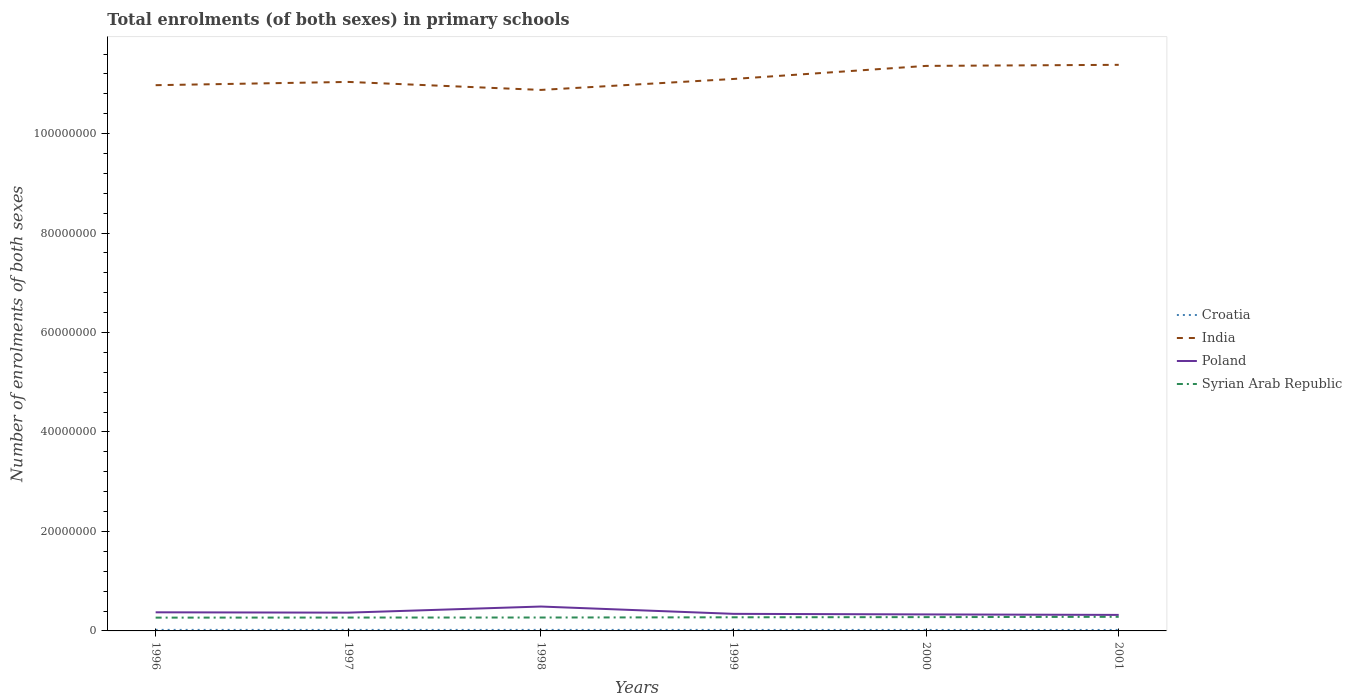Does the line corresponding to Syrian Arab Republic intersect with the line corresponding to India?
Offer a terse response. No. Across all years, what is the maximum number of enrolments in primary schools in Poland?
Offer a very short reply. 3.22e+06. In which year was the number of enrolments in primary schools in India maximum?
Keep it short and to the point. 1998. What is the total number of enrolments in primary schools in India in the graph?
Your answer should be compact. -3.44e+06. What is the difference between the highest and the second highest number of enrolments in primary schools in India?
Make the answer very short. 5.05e+06. What is the difference between the highest and the lowest number of enrolments in primary schools in Syrian Arab Republic?
Keep it short and to the point. 3. Is the number of enrolments in primary schools in Croatia strictly greater than the number of enrolments in primary schools in Syrian Arab Republic over the years?
Your response must be concise. Yes. What is the difference between two consecutive major ticks on the Y-axis?
Ensure brevity in your answer.  2.00e+07. Does the graph contain any zero values?
Keep it short and to the point. No. Does the graph contain grids?
Provide a succinct answer. No. How many legend labels are there?
Ensure brevity in your answer.  4. How are the legend labels stacked?
Your response must be concise. Vertical. What is the title of the graph?
Give a very brief answer. Total enrolments (of both sexes) in primary schools. What is the label or title of the Y-axis?
Make the answer very short. Number of enrolments of both sexes. What is the Number of enrolments of both sexes of Croatia in 1996?
Offer a terse response. 2.08e+05. What is the Number of enrolments of both sexes in India in 1996?
Ensure brevity in your answer.  1.10e+08. What is the Number of enrolments of both sexes in Poland in 1996?
Your answer should be very brief. 3.74e+06. What is the Number of enrolments of both sexes in Syrian Arab Republic in 1996?
Provide a succinct answer. 2.67e+06. What is the Number of enrolments of both sexes of Croatia in 1997?
Offer a very short reply. 2.04e+05. What is the Number of enrolments of both sexes in India in 1997?
Your answer should be very brief. 1.10e+08. What is the Number of enrolments of both sexes in Poland in 1997?
Keep it short and to the point. 3.67e+06. What is the Number of enrolments of both sexes in Syrian Arab Republic in 1997?
Your answer should be very brief. 2.69e+06. What is the Number of enrolments of both sexes of Croatia in 1998?
Make the answer very short. 2.06e+05. What is the Number of enrolments of both sexes in India in 1998?
Provide a short and direct response. 1.09e+08. What is the Number of enrolments of both sexes in Poland in 1998?
Your answer should be very brief. 4.91e+06. What is the Number of enrolments of both sexes of Syrian Arab Republic in 1998?
Your answer should be very brief. 2.70e+06. What is the Number of enrolments of both sexes of Croatia in 1999?
Provide a succinct answer. 2.03e+05. What is the Number of enrolments of both sexes of India in 1999?
Give a very brief answer. 1.11e+08. What is the Number of enrolments of both sexes of Poland in 1999?
Offer a very short reply. 3.43e+06. What is the Number of enrolments of both sexes of Syrian Arab Republic in 1999?
Provide a short and direct response. 2.74e+06. What is the Number of enrolments of both sexes of Croatia in 2000?
Provide a short and direct response. 1.99e+05. What is the Number of enrolments of both sexes in India in 2000?
Provide a short and direct response. 1.14e+08. What is the Number of enrolments of both sexes of Poland in 2000?
Your response must be concise. 3.32e+06. What is the Number of enrolments of both sexes of Syrian Arab Republic in 2000?
Provide a succinct answer. 2.77e+06. What is the Number of enrolments of both sexes in Croatia in 2001?
Provide a short and direct response. 1.96e+05. What is the Number of enrolments of both sexes of India in 2001?
Give a very brief answer. 1.14e+08. What is the Number of enrolments of both sexes in Poland in 2001?
Offer a terse response. 3.22e+06. What is the Number of enrolments of both sexes in Syrian Arab Republic in 2001?
Give a very brief answer. 2.84e+06. Across all years, what is the maximum Number of enrolments of both sexes of Croatia?
Offer a terse response. 2.08e+05. Across all years, what is the maximum Number of enrolments of both sexes in India?
Give a very brief answer. 1.14e+08. Across all years, what is the maximum Number of enrolments of both sexes of Poland?
Provide a succinct answer. 4.91e+06. Across all years, what is the maximum Number of enrolments of both sexes in Syrian Arab Republic?
Provide a succinct answer. 2.84e+06. Across all years, what is the minimum Number of enrolments of both sexes of Croatia?
Ensure brevity in your answer.  1.96e+05. Across all years, what is the minimum Number of enrolments of both sexes in India?
Your answer should be very brief. 1.09e+08. Across all years, what is the minimum Number of enrolments of both sexes in Poland?
Your response must be concise. 3.22e+06. Across all years, what is the minimum Number of enrolments of both sexes of Syrian Arab Republic?
Your answer should be compact. 2.67e+06. What is the total Number of enrolments of both sexes of Croatia in the graph?
Make the answer very short. 1.22e+06. What is the total Number of enrolments of both sexes of India in the graph?
Keep it short and to the point. 6.67e+08. What is the total Number of enrolments of both sexes of Poland in the graph?
Provide a succinct answer. 2.23e+07. What is the total Number of enrolments of both sexes in Syrian Arab Republic in the graph?
Make the answer very short. 1.64e+07. What is the difference between the Number of enrolments of both sexes in Croatia in 1996 and that in 1997?
Make the answer very short. 3957. What is the difference between the Number of enrolments of both sexes in India in 1996 and that in 1997?
Offer a terse response. -6.56e+05. What is the difference between the Number of enrolments of both sexes in Poland in 1996 and that in 1997?
Ensure brevity in your answer.  6.57e+04. What is the difference between the Number of enrolments of both sexes in Syrian Arab Republic in 1996 and that in 1997?
Your response must be concise. -1.72e+04. What is the difference between the Number of enrolments of both sexes in Croatia in 1996 and that in 1998?
Ensure brevity in your answer.  1769. What is the difference between the Number of enrolments of both sexes of India in 1996 and that in 1998?
Keep it short and to the point. 9.52e+05. What is the difference between the Number of enrolments of both sexes in Poland in 1996 and that in 1998?
Provide a succinct answer. -1.16e+06. What is the difference between the Number of enrolments of both sexes of Syrian Arab Republic in 1996 and that in 1998?
Make the answer very short. -2.25e+04. What is the difference between the Number of enrolments of both sexes of Croatia in 1996 and that in 1999?
Make the answer very short. 4891. What is the difference between the Number of enrolments of both sexes in India in 1996 and that in 1999?
Offer a terse response. -1.25e+06. What is the difference between the Number of enrolments of both sexes in Poland in 1996 and that in 1999?
Your answer should be very brief. 3.07e+05. What is the difference between the Number of enrolments of both sexes of Syrian Arab Republic in 1996 and that in 1999?
Keep it short and to the point. -6.51e+04. What is the difference between the Number of enrolments of both sexes of Croatia in 1996 and that in 2000?
Offer a terse response. 8806. What is the difference between the Number of enrolments of both sexes of India in 1996 and that in 2000?
Your response must be concise. -3.88e+06. What is the difference between the Number of enrolments of both sexes in Poland in 1996 and that in 2000?
Ensure brevity in your answer.  4.22e+05. What is the difference between the Number of enrolments of both sexes in Syrian Arab Republic in 1996 and that in 2000?
Offer a terse response. -1.02e+05. What is the difference between the Number of enrolments of both sexes of Croatia in 1996 and that in 2001?
Give a very brief answer. 1.23e+04. What is the difference between the Number of enrolments of both sexes in India in 1996 and that in 2001?
Make the answer very short. -4.09e+06. What is the difference between the Number of enrolments of both sexes in Poland in 1996 and that in 2001?
Offer a terse response. 5.19e+05. What is the difference between the Number of enrolments of both sexes in Syrian Arab Republic in 1996 and that in 2001?
Offer a terse response. -1.62e+05. What is the difference between the Number of enrolments of both sexes of Croatia in 1997 and that in 1998?
Keep it short and to the point. -2188. What is the difference between the Number of enrolments of both sexes of India in 1997 and that in 1998?
Provide a short and direct response. 1.61e+06. What is the difference between the Number of enrolments of both sexes of Poland in 1997 and that in 1998?
Make the answer very short. -1.23e+06. What is the difference between the Number of enrolments of both sexes in Syrian Arab Republic in 1997 and that in 1998?
Offer a terse response. -5247. What is the difference between the Number of enrolments of both sexes in Croatia in 1997 and that in 1999?
Keep it short and to the point. 934. What is the difference between the Number of enrolments of both sexes in India in 1997 and that in 1999?
Your response must be concise. -5.95e+05. What is the difference between the Number of enrolments of both sexes in Poland in 1997 and that in 1999?
Your answer should be compact. 2.41e+05. What is the difference between the Number of enrolments of both sexes of Syrian Arab Republic in 1997 and that in 1999?
Provide a succinct answer. -4.79e+04. What is the difference between the Number of enrolments of both sexes of Croatia in 1997 and that in 2000?
Ensure brevity in your answer.  4849. What is the difference between the Number of enrolments of both sexes in India in 1997 and that in 2000?
Keep it short and to the point. -3.22e+06. What is the difference between the Number of enrolments of both sexes in Poland in 1997 and that in 2000?
Your response must be concise. 3.56e+05. What is the difference between the Number of enrolments of both sexes of Syrian Arab Republic in 1997 and that in 2000?
Offer a very short reply. -8.47e+04. What is the difference between the Number of enrolments of both sexes of Croatia in 1997 and that in 2001?
Make the answer very short. 8295. What is the difference between the Number of enrolments of both sexes of India in 1997 and that in 2001?
Keep it short and to the point. -3.44e+06. What is the difference between the Number of enrolments of both sexes in Poland in 1997 and that in 2001?
Your answer should be compact. 4.53e+05. What is the difference between the Number of enrolments of both sexes of Syrian Arab Republic in 1997 and that in 2001?
Offer a very short reply. -1.45e+05. What is the difference between the Number of enrolments of both sexes in Croatia in 1998 and that in 1999?
Offer a terse response. 3122. What is the difference between the Number of enrolments of both sexes of India in 1998 and that in 1999?
Provide a short and direct response. -2.20e+06. What is the difference between the Number of enrolments of both sexes of Poland in 1998 and that in 1999?
Make the answer very short. 1.47e+06. What is the difference between the Number of enrolments of both sexes in Syrian Arab Republic in 1998 and that in 1999?
Ensure brevity in your answer.  -4.26e+04. What is the difference between the Number of enrolments of both sexes of Croatia in 1998 and that in 2000?
Give a very brief answer. 7037. What is the difference between the Number of enrolments of both sexes in India in 1998 and that in 2000?
Provide a short and direct response. -4.83e+06. What is the difference between the Number of enrolments of both sexes of Poland in 1998 and that in 2000?
Offer a terse response. 1.59e+06. What is the difference between the Number of enrolments of both sexes of Syrian Arab Republic in 1998 and that in 2000?
Your answer should be compact. -7.95e+04. What is the difference between the Number of enrolments of both sexes in Croatia in 1998 and that in 2001?
Your answer should be very brief. 1.05e+04. What is the difference between the Number of enrolments of both sexes in India in 1998 and that in 2001?
Ensure brevity in your answer.  -5.05e+06. What is the difference between the Number of enrolments of both sexes of Poland in 1998 and that in 2001?
Your answer should be very brief. 1.68e+06. What is the difference between the Number of enrolments of both sexes of Syrian Arab Republic in 1998 and that in 2001?
Offer a terse response. -1.40e+05. What is the difference between the Number of enrolments of both sexes in Croatia in 1999 and that in 2000?
Your answer should be very brief. 3915. What is the difference between the Number of enrolments of both sexes in India in 1999 and that in 2000?
Ensure brevity in your answer.  -2.63e+06. What is the difference between the Number of enrolments of both sexes of Poland in 1999 and that in 2000?
Your answer should be compact. 1.15e+05. What is the difference between the Number of enrolments of both sexes in Syrian Arab Republic in 1999 and that in 2000?
Keep it short and to the point. -3.68e+04. What is the difference between the Number of enrolments of both sexes of Croatia in 1999 and that in 2001?
Ensure brevity in your answer.  7361. What is the difference between the Number of enrolments of both sexes of India in 1999 and that in 2001?
Offer a terse response. -2.84e+06. What is the difference between the Number of enrolments of both sexes in Poland in 1999 and that in 2001?
Give a very brief answer. 2.13e+05. What is the difference between the Number of enrolments of both sexes in Syrian Arab Republic in 1999 and that in 2001?
Provide a succinct answer. -9.69e+04. What is the difference between the Number of enrolments of both sexes of Croatia in 2000 and that in 2001?
Make the answer very short. 3446. What is the difference between the Number of enrolments of both sexes in India in 2000 and that in 2001?
Offer a very short reply. -2.14e+05. What is the difference between the Number of enrolments of both sexes of Poland in 2000 and that in 2001?
Give a very brief answer. 9.75e+04. What is the difference between the Number of enrolments of both sexes of Syrian Arab Republic in 2000 and that in 2001?
Give a very brief answer. -6.01e+04. What is the difference between the Number of enrolments of both sexes in Croatia in 1996 and the Number of enrolments of both sexes in India in 1997?
Offer a terse response. -1.10e+08. What is the difference between the Number of enrolments of both sexes in Croatia in 1996 and the Number of enrolments of both sexes in Poland in 1997?
Your answer should be very brief. -3.47e+06. What is the difference between the Number of enrolments of both sexes in Croatia in 1996 and the Number of enrolments of both sexes in Syrian Arab Republic in 1997?
Provide a short and direct response. -2.48e+06. What is the difference between the Number of enrolments of both sexes of India in 1996 and the Number of enrolments of both sexes of Poland in 1997?
Make the answer very short. 1.06e+08. What is the difference between the Number of enrolments of both sexes in India in 1996 and the Number of enrolments of both sexes in Syrian Arab Republic in 1997?
Offer a terse response. 1.07e+08. What is the difference between the Number of enrolments of both sexes in Poland in 1996 and the Number of enrolments of both sexes in Syrian Arab Republic in 1997?
Offer a terse response. 1.05e+06. What is the difference between the Number of enrolments of both sexes of Croatia in 1996 and the Number of enrolments of both sexes of India in 1998?
Provide a succinct answer. -1.09e+08. What is the difference between the Number of enrolments of both sexes of Croatia in 1996 and the Number of enrolments of both sexes of Poland in 1998?
Make the answer very short. -4.70e+06. What is the difference between the Number of enrolments of both sexes in Croatia in 1996 and the Number of enrolments of both sexes in Syrian Arab Republic in 1998?
Provide a succinct answer. -2.49e+06. What is the difference between the Number of enrolments of both sexes in India in 1996 and the Number of enrolments of both sexes in Poland in 1998?
Offer a very short reply. 1.05e+08. What is the difference between the Number of enrolments of both sexes in India in 1996 and the Number of enrolments of both sexes in Syrian Arab Republic in 1998?
Your response must be concise. 1.07e+08. What is the difference between the Number of enrolments of both sexes of Poland in 1996 and the Number of enrolments of both sexes of Syrian Arab Republic in 1998?
Keep it short and to the point. 1.04e+06. What is the difference between the Number of enrolments of both sexes in Croatia in 1996 and the Number of enrolments of both sexes in India in 1999?
Ensure brevity in your answer.  -1.11e+08. What is the difference between the Number of enrolments of both sexes of Croatia in 1996 and the Number of enrolments of both sexes of Poland in 1999?
Provide a short and direct response. -3.23e+06. What is the difference between the Number of enrolments of both sexes in Croatia in 1996 and the Number of enrolments of both sexes in Syrian Arab Republic in 1999?
Offer a terse response. -2.53e+06. What is the difference between the Number of enrolments of both sexes in India in 1996 and the Number of enrolments of both sexes in Poland in 1999?
Give a very brief answer. 1.06e+08. What is the difference between the Number of enrolments of both sexes of India in 1996 and the Number of enrolments of both sexes of Syrian Arab Republic in 1999?
Provide a succinct answer. 1.07e+08. What is the difference between the Number of enrolments of both sexes in Poland in 1996 and the Number of enrolments of both sexes in Syrian Arab Republic in 1999?
Your answer should be very brief. 1.00e+06. What is the difference between the Number of enrolments of both sexes in Croatia in 1996 and the Number of enrolments of both sexes in India in 2000?
Give a very brief answer. -1.13e+08. What is the difference between the Number of enrolments of both sexes in Croatia in 1996 and the Number of enrolments of both sexes in Poland in 2000?
Make the answer very short. -3.11e+06. What is the difference between the Number of enrolments of both sexes of Croatia in 1996 and the Number of enrolments of both sexes of Syrian Arab Republic in 2000?
Ensure brevity in your answer.  -2.57e+06. What is the difference between the Number of enrolments of both sexes in India in 1996 and the Number of enrolments of both sexes in Poland in 2000?
Keep it short and to the point. 1.06e+08. What is the difference between the Number of enrolments of both sexes in India in 1996 and the Number of enrolments of both sexes in Syrian Arab Republic in 2000?
Offer a terse response. 1.07e+08. What is the difference between the Number of enrolments of both sexes in Poland in 1996 and the Number of enrolments of both sexes in Syrian Arab Republic in 2000?
Provide a succinct answer. 9.65e+05. What is the difference between the Number of enrolments of both sexes in Croatia in 1996 and the Number of enrolments of both sexes in India in 2001?
Your response must be concise. -1.14e+08. What is the difference between the Number of enrolments of both sexes of Croatia in 1996 and the Number of enrolments of both sexes of Poland in 2001?
Keep it short and to the point. -3.01e+06. What is the difference between the Number of enrolments of both sexes in Croatia in 1996 and the Number of enrolments of both sexes in Syrian Arab Republic in 2001?
Ensure brevity in your answer.  -2.63e+06. What is the difference between the Number of enrolments of both sexes in India in 1996 and the Number of enrolments of both sexes in Poland in 2001?
Give a very brief answer. 1.07e+08. What is the difference between the Number of enrolments of both sexes in India in 1996 and the Number of enrolments of both sexes in Syrian Arab Republic in 2001?
Give a very brief answer. 1.07e+08. What is the difference between the Number of enrolments of both sexes in Poland in 1996 and the Number of enrolments of both sexes in Syrian Arab Republic in 2001?
Keep it short and to the point. 9.05e+05. What is the difference between the Number of enrolments of both sexes of Croatia in 1997 and the Number of enrolments of both sexes of India in 1998?
Keep it short and to the point. -1.09e+08. What is the difference between the Number of enrolments of both sexes in Croatia in 1997 and the Number of enrolments of both sexes in Poland in 1998?
Provide a succinct answer. -4.70e+06. What is the difference between the Number of enrolments of both sexes in Croatia in 1997 and the Number of enrolments of both sexes in Syrian Arab Republic in 1998?
Keep it short and to the point. -2.49e+06. What is the difference between the Number of enrolments of both sexes in India in 1997 and the Number of enrolments of both sexes in Poland in 1998?
Offer a terse response. 1.05e+08. What is the difference between the Number of enrolments of both sexes in India in 1997 and the Number of enrolments of both sexes in Syrian Arab Republic in 1998?
Keep it short and to the point. 1.08e+08. What is the difference between the Number of enrolments of both sexes in Poland in 1997 and the Number of enrolments of both sexes in Syrian Arab Republic in 1998?
Give a very brief answer. 9.79e+05. What is the difference between the Number of enrolments of both sexes in Croatia in 1997 and the Number of enrolments of both sexes in India in 1999?
Offer a very short reply. -1.11e+08. What is the difference between the Number of enrolments of both sexes of Croatia in 1997 and the Number of enrolments of both sexes of Poland in 1999?
Your response must be concise. -3.23e+06. What is the difference between the Number of enrolments of both sexes in Croatia in 1997 and the Number of enrolments of both sexes in Syrian Arab Republic in 1999?
Give a very brief answer. -2.53e+06. What is the difference between the Number of enrolments of both sexes in India in 1997 and the Number of enrolments of both sexes in Poland in 1999?
Your answer should be compact. 1.07e+08. What is the difference between the Number of enrolments of both sexes in India in 1997 and the Number of enrolments of both sexes in Syrian Arab Republic in 1999?
Your answer should be compact. 1.08e+08. What is the difference between the Number of enrolments of both sexes of Poland in 1997 and the Number of enrolments of both sexes of Syrian Arab Republic in 1999?
Your answer should be compact. 9.37e+05. What is the difference between the Number of enrolments of both sexes in Croatia in 1997 and the Number of enrolments of both sexes in India in 2000?
Make the answer very short. -1.13e+08. What is the difference between the Number of enrolments of both sexes of Croatia in 1997 and the Number of enrolments of both sexes of Poland in 2000?
Ensure brevity in your answer.  -3.11e+06. What is the difference between the Number of enrolments of both sexes of Croatia in 1997 and the Number of enrolments of both sexes of Syrian Arab Republic in 2000?
Offer a very short reply. -2.57e+06. What is the difference between the Number of enrolments of both sexes in India in 1997 and the Number of enrolments of both sexes in Poland in 2000?
Offer a terse response. 1.07e+08. What is the difference between the Number of enrolments of both sexes in India in 1997 and the Number of enrolments of both sexes in Syrian Arab Republic in 2000?
Your answer should be compact. 1.08e+08. What is the difference between the Number of enrolments of both sexes in Poland in 1997 and the Number of enrolments of both sexes in Syrian Arab Republic in 2000?
Keep it short and to the point. 9.00e+05. What is the difference between the Number of enrolments of both sexes in Croatia in 1997 and the Number of enrolments of both sexes in India in 2001?
Keep it short and to the point. -1.14e+08. What is the difference between the Number of enrolments of both sexes of Croatia in 1997 and the Number of enrolments of both sexes of Poland in 2001?
Provide a succinct answer. -3.02e+06. What is the difference between the Number of enrolments of both sexes in Croatia in 1997 and the Number of enrolments of both sexes in Syrian Arab Republic in 2001?
Make the answer very short. -2.63e+06. What is the difference between the Number of enrolments of both sexes of India in 1997 and the Number of enrolments of both sexes of Poland in 2001?
Provide a short and direct response. 1.07e+08. What is the difference between the Number of enrolments of both sexes in India in 1997 and the Number of enrolments of both sexes in Syrian Arab Republic in 2001?
Your answer should be very brief. 1.08e+08. What is the difference between the Number of enrolments of both sexes of Poland in 1997 and the Number of enrolments of both sexes of Syrian Arab Republic in 2001?
Offer a terse response. 8.40e+05. What is the difference between the Number of enrolments of both sexes in Croatia in 1998 and the Number of enrolments of both sexes in India in 1999?
Provide a short and direct response. -1.11e+08. What is the difference between the Number of enrolments of both sexes of Croatia in 1998 and the Number of enrolments of both sexes of Poland in 1999?
Provide a succinct answer. -3.23e+06. What is the difference between the Number of enrolments of both sexes of Croatia in 1998 and the Number of enrolments of both sexes of Syrian Arab Republic in 1999?
Provide a succinct answer. -2.53e+06. What is the difference between the Number of enrolments of both sexes in India in 1998 and the Number of enrolments of both sexes in Poland in 1999?
Your answer should be compact. 1.05e+08. What is the difference between the Number of enrolments of both sexes of India in 1998 and the Number of enrolments of both sexes of Syrian Arab Republic in 1999?
Provide a short and direct response. 1.06e+08. What is the difference between the Number of enrolments of both sexes of Poland in 1998 and the Number of enrolments of both sexes of Syrian Arab Republic in 1999?
Your answer should be compact. 2.17e+06. What is the difference between the Number of enrolments of both sexes in Croatia in 1998 and the Number of enrolments of both sexes in India in 2000?
Keep it short and to the point. -1.13e+08. What is the difference between the Number of enrolments of both sexes of Croatia in 1998 and the Number of enrolments of both sexes of Poland in 2000?
Provide a short and direct response. -3.11e+06. What is the difference between the Number of enrolments of both sexes in Croatia in 1998 and the Number of enrolments of both sexes in Syrian Arab Republic in 2000?
Keep it short and to the point. -2.57e+06. What is the difference between the Number of enrolments of both sexes of India in 1998 and the Number of enrolments of both sexes of Poland in 2000?
Give a very brief answer. 1.05e+08. What is the difference between the Number of enrolments of both sexes of India in 1998 and the Number of enrolments of both sexes of Syrian Arab Republic in 2000?
Offer a terse response. 1.06e+08. What is the difference between the Number of enrolments of both sexes in Poland in 1998 and the Number of enrolments of both sexes in Syrian Arab Republic in 2000?
Offer a very short reply. 2.13e+06. What is the difference between the Number of enrolments of both sexes of Croatia in 1998 and the Number of enrolments of both sexes of India in 2001?
Offer a terse response. -1.14e+08. What is the difference between the Number of enrolments of both sexes in Croatia in 1998 and the Number of enrolments of both sexes in Poland in 2001?
Offer a terse response. -3.02e+06. What is the difference between the Number of enrolments of both sexes of Croatia in 1998 and the Number of enrolments of both sexes of Syrian Arab Republic in 2001?
Give a very brief answer. -2.63e+06. What is the difference between the Number of enrolments of both sexes of India in 1998 and the Number of enrolments of both sexes of Poland in 2001?
Make the answer very short. 1.06e+08. What is the difference between the Number of enrolments of both sexes in India in 1998 and the Number of enrolments of both sexes in Syrian Arab Republic in 2001?
Your answer should be compact. 1.06e+08. What is the difference between the Number of enrolments of both sexes of Poland in 1998 and the Number of enrolments of both sexes of Syrian Arab Republic in 2001?
Provide a short and direct response. 2.07e+06. What is the difference between the Number of enrolments of both sexes in Croatia in 1999 and the Number of enrolments of both sexes in India in 2000?
Keep it short and to the point. -1.13e+08. What is the difference between the Number of enrolments of both sexes of Croatia in 1999 and the Number of enrolments of both sexes of Poland in 2000?
Provide a succinct answer. -3.12e+06. What is the difference between the Number of enrolments of both sexes in Croatia in 1999 and the Number of enrolments of both sexes in Syrian Arab Republic in 2000?
Your answer should be very brief. -2.57e+06. What is the difference between the Number of enrolments of both sexes in India in 1999 and the Number of enrolments of both sexes in Poland in 2000?
Give a very brief answer. 1.08e+08. What is the difference between the Number of enrolments of both sexes in India in 1999 and the Number of enrolments of both sexes in Syrian Arab Republic in 2000?
Provide a succinct answer. 1.08e+08. What is the difference between the Number of enrolments of both sexes of Poland in 1999 and the Number of enrolments of both sexes of Syrian Arab Republic in 2000?
Give a very brief answer. 6.59e+05. What is the difference between the Number of enrolments of both sexes of Croatia in 1999 and the Number of enrolments of both sexes of India in 2001?
Ensure brevity in your answer.  -1.14e+08. What is the difference between the Number of enrolments of both sexes in Croatia in 1999 and the Number of enrolments of both sexes in Poland in 2001?
Offer a very short reply. -3.02e+06. What is the difference between the Number of enrolments of both sexes of Croatia in 1999 and the Number of enrolments of both sexes of Syrian Arab Republic in 2001?
Ensure brevity in your answer.  -2.63e+06. What is the difference between the Number of enrolments of both sexes of India in 1999 and the Number of enrolments of both sexes of Poland in 2001?
Make the answer very short. 1.08e+08. What is the difference between the Number of enrolments of both sexes of India in 1999 and the Number of enrolments of both sexes of Syrian Arab Republic in 2001?
Offer a terse response. 1.08e+08. What is the difference between the Number of enrolments of both sexes in Poland in 1999 and the Number of enrolments of both sexes in Syrian Arab Republic in 2001?
Give a very brief answer. 5.99e+05. What is the difference between the Number of enrolments of both sexes in Croatia in 2000 and the Number of enrolments of both sexes in India in 2001?
Provide a succinct answer. -1.14e+08. What is the difference between the Number of enrolments of both sexes in Croatia in 2000 and the Number of enrolments of both sexes in Poland in 2001?
Your answer should be very brief. -3.02e+06. What is the difference between the Number of enrolments of both sexes in Croatia in 2000 and the Number of enrolments of both sexes in Syrian Arab Republic in 2001?
Provide a succinct answer. -2.64e+06. What is the difference between the Number of enrolments of both sexes of India in 2000 and the Number of enrolments of both sexes of Poland in 2001?
Make the answer very short. 1.10e+08. What is the difference between the Number of enrolments of both sexes of India in 2000 and the Number of enrolments of both sexes of Syrian Arab Republic in 2001?
Provide a succinct answer. 1.11e+08. What is the difference between the Number of enrolments of both sexes of Poland in 2000 and the Number of enrolments of both sexes of Syrian Arab Republic in 2001?
Offer a terse response. 4.84e+05. What is the average Number of enrolments of both sexes of Croatia per year?
Keep it short and to the point. 2.03e+05. What is the average Number of enrolments of both sexes in India per year?
Give a very brief answer. 1.11e+08. What is the average Number of enrolments of both sexes in Poland per year?
Your answer should be very brief. 3.72e+06. What is the average Number of enrolments of both sexes in Syrian Arab Republic per year?
Ensure brevity in your answer.  2.73e+06. In the year 1996, what is the difference between the Number of enrolments of both sexes of Croatia and Number of enrolments of both sexes of India?
Offer a terse response. -1.10e+08. In the year 1996, what is the difference between the Number of enrolments of both sexes in Croatia and Number of enrolments of both sexes in Poland?
Offer a terse response. -3.53e+06. In the year 1996, what is the difference between the Number of enrolments of both sexes in Croatia and Number of enrolments of both sexes in Syrian Arab Republic?
Give a very brief answer. -2.47e+06. In the year 1996, what is the difference between the Number of enrolments of both sexes in India and Number of enrolments of both sexes in Poland?
Your answer should be very brief. 1.06e+08. In the year 1996, what is the difference between the Number of enrolments of both sexes in India and Number of enrolments of both sexes in Syrian Arab Republic?
Provide a succinct answer. 1.07e+08. In the year 1996, what is the difference between the Number of enrolments of both sexes of Poland and Number of enrolments of both sexes of Syrian Arab Republic?
Your answer should be very brief. 1.07e+06. In the year 1997, what is the difference between the Number of enrolments of both sexes of Croatia and Number of enrolments of both sexes of India?
Your response must be concise. -1.10e+08. In the year 1997, what is the difference between the Number of enrolments of both sexes in Croatia and Number of enrolments of both sexes in Poland?
Provide a succinct answer. -3.47e+06. In the year 1997, what is the difference between the Number of enrolments of both sexes of Croatia and Number of enrolments of both sexes of Syrian Arab Republic?
Offer a terse response. -2.49e+06. In the year 1997, what is the difference between the Number of enrolments of both sexes of India and Number of enrolments of both sexes of Poland?
Give a very brief answer. 1.07e+08. In the year 1997, what is the difference between the Number of enrolments of both sexes of India and Number of enrolments of both sexes of Syrian Arab Republic?
Offer a very short reply. 1.08e+08. In the year 1997, what is the difference between the Number of enrolments of both sexes of Poland and Number of enrolments of both sexes of Syrian Arab Republic?
Provide a short and direct response. 9.84e+05. In the year 1998, what is the difference between the Number of enrolments of both sexes in Croatia and Number of enrolments of both sexes in India?
Your response must be concise. -1.09e+08. In the year 1998, what is the difference between the Number of enrolments of both sexes in Croatia and Number of enrolments of both sexes in Poland?
Offer a very short reply. -4.70e+06. In the year 1998, what is the difference between the Number of enrolments of both sexes in Croatia and Number of enrolments of both sexes in Syrian Arab Republic?
Provide a short and direct response. -2.49e+06. In the year 1998, what is the difference between the Number of enrolments of both sexes of India and Number of enrolments of both sexes of Poland?
Offer a terse response. 1.04e+08. In the year 1998, what is the difference between the Number of enrolments of both sexes in India and Number of enrolments of both sexes in Syrian Arab Republic?
Make the answer very short. 1.06e+08. In the year 1998, what is the difference between the Number of enrolments of both sexes of Poland and Number of enrolments of both sexes of Syrian Arab Republic?
Your answer should be compact. 2.21e+06. In the year 1999, what is the difference between the Number of enrolments of both sexes in Croatia and Number of enrolments of both sexes in India?
Give a very brief answer. -1.11e+08. In the year 1999, what is the difference between the Number of enrolments of both sexes in Croatia and Number of enrolments of both sexes in Poland?
Your answer should be compact. -3.23e+06. In the year 1999, what is the difference between the Number of enrolments of both sexes in Croatia and Number of enrolments of both sexes in Syrian Arab Republic?
Keep it short and to the point. -2.54e+06. In the year 1999, what is the difference between the Number of enrolments of both sexes of India and Number of enrolments of both sexes of Poland?
Your response must be concise. 1.08e+08. In the year 1999, what is the difference between the Number of enrolments of both sexes of India and Number of enrolments of both sexes of Syrian Arab Republic?
Your answer should be very brief. 1.08e+08. In the year 1999, what is the difference between the Number of enrolments of both sexes in Poland and Number of enrolments of both sexes in Syrian Arab Republic?
Your answer should be very brief. 6.96e+05. In the year 2000, what is the difference between the Number of enrolments of both sexes in Croatia and Number of enrolments of both sexes in India?
Ensure brevity in your answer.  -1.13e+08. In the year 2000, what is the difference between the Number of enrolments of both sexes in Croatia and Number of enrolments of both sexes in Poland?
Give a very brief answer. -3.12e+06. In the year 2000, what is the difference between the Number of enrolments of both sexes in Croatia and Number of enrolments of both sexes in Syrian Arab Republic?
Give a very brief answer. -2.58e+06. In the year 2000, what is the difference between the Number of enrolments of both sexes of India and Number of enrolments of both sexes of Poland?
Your response must be concise. 1.10e+08. In the year 2000, what is the difference between the Number of enrolments of both sexes in India and Number of enrolments of both sexes in Syrian Arab Republic?
Your response must be concise. 1.11e+08. In the year 2000, what is the difference between the Number of enrolments of both sexes in Poland and Number of enrolments of both sexes in Syrian Arab Republic?
Give a very brief answer. 5.44e+05. In the year 2001, what is the difference between the Number of enrolments of both sexes of Croatia and Number of enrolments of both sexes of India?
Your answer should be very brief. -1.14e+08. In the year 2001, what is the difference between the Number of enrolments of both sexes in Croatia and Number of enrolments of both sexes in Poland?
Your answer should be compact. -3.03e+06. In the year 2001, what is the difference between the Number of enrolments of both sexes of Croatia and Number of enrolments of both sexes of Syrian Arab Republic?
Provide a short and direct response. -2.64e+06. In the year 2001, what is the difference between the Number of enrolments of both sexes in India and Number of enrolments of both sexes in Poland?
Your answer should be compact. 1.11e+08. In the year 2001, what is the difference between the Number of enrolments of both sexes of India and Number of enrolments of both sexes of Syrian Arab Republic?
Provide a succinct answer. 1.11e+08. In the year 2001, what is the difference between the Number of enrolments of both sexes in Poland and Number of enrolments of both sexes in Syrian Arab Republic?
Provide a short and direct response. 3.86e+05. What is the ratio of the Number of enrolments of both sexes of Croatia in 1996 to that in 1997?
Make the answer very short. 1.02. What is the ratio of the Number of enrolments of both sexes in Poland in 1996 to that in 1997?
Offer a very short reply. 1.02. What is the ratio of the Number of enrolments of both sexes in Croatia in 1996 to that in 1998?
Your answer should be compact. 1.01. What is the ratio of the Number of enrolments of both sexes in India in 1996 to that in 1998?
Your answer should be very brief. 1.01. What is the ratio of the Number of enrolments of both sexes of Poland in 1996 to that in 1998?
Your answer should be very brief. 0.76. What is the ratio of the Number of enrolments of both sexes in Croatia in 1996 to that in 1999?
Keep it short and to the point. 1.02. What is the ratio of the Number of enrolments of both sexes of India in 1996 to that in 1999?
Give a very brief answer. 0.99. What is the ratio of the Number of enrolments of both sexes in Poland in 1996 to that in 1999?
Your response must be concise. 1.09. What is the ratio of the Number of enrolments of both sexes of Syrian Arab Republic in 1996 to that in 1999?
Your answer should be compact. 0.98. What is the ratio of the Number of enrolments of both sexes in Croatia in 1996 to that in 2000?
Ensure brevity in your answer.  1.04. What is the ratio of the Number of enrolments of both sexes in India in 1996 to that in 2000?
Offer a terse response. 0.97. What is the ratio of the Number of enrolments of both sexes in Poland in 1996 to that in 2000?
Make the answer very short. 1.13. What is the ratio of the Number of enrolments of both sexes in Syrian Arab Republic in 1996 to that in 2000?
Your answer should be compact. 0.96. What is the ratio of the Number of enrolments of both sexes of Croatia in 1996 to that in 2001?
Offer a very short reply. 1.06. What is the ratio of the Number of enrolments of both sexes in India in 1996 to that in 2001?
Offer a terse response. 0.96. What is the ratio of the Number of enrolments of both sexes of Poland in 1996 to that in 2001?
Keep it short and to the point. 1.16. What is the ratio of the Number of enrolments of both sexes in Syrian Arab Republic in 1996 to that in 2001?
Your answer should be very brief. 0.94. What is the ratio of the Number of enrolments of both sexes in Croatia in 1997 to that in 1998?
Keep it short and to the point. 0.99. What is the ratio of the Number of enrolments of both sexes in India in 1997 to that in 1998?
Your response must be concise. 1.01. What is the ratio of the Number of enrolments of both sexes in Poland in 1997 to that in 1998?
Your answer should be very brief. 0.75. What is the ratio of the Number of enrolments of both sexes of Syrian Arab Republic in 1997 to that in 1998?
Provide a succinct answer. 1. What is the ratio of the Number of enrolments of both sexes of India in 1997 to that in 1999?
Provide a succinct answer. 0.99. What is the ratio of the Number of enrolments of both sexes in Poland in 1997 to that in 1999?
Ensure brevity in your answer.  1.07. What is the ratio of the Number of enrolments of both sexes in Syrian Arab Republic in 1997 to that in 1999?
Make the answer very short. 0.98. What is the ratio of the Number of enrolments of both sexes of Croatia in 1997 to that in 2000?
Give a very brief answer. 1.02. What is the ratio of the Number of enrolments of both sexes of India in 1997 to that in 2000?
Your answer should be very brief. 0.97. What is the ratio of the Number of enrolments of both sexes in Poland in 1997 to that in 2000?
Ensure brevity in your answer.  1.11. What is the ratio of the Number of enrolments of both sexes of Syrian Arab Republic in 1997 to that in 2000?
Provide a short and direct response. 0.97. What is the ratio of the Number of enrolments of both sexes in Croatia in 1997 to that in 2001?
Make the answer very short. 1.04. What is the ratio of the Number of enrolments of both sexes of India in 1997 to that in 2001?
Offer a very short reply. 0.97. What is the ratio of the Number of enrolments of both sexes of Poland in 1997 to that in 2001?
Provide a succinct answer. 1.14. What is the ratio of the Number of enrolments of both sexes of Syrian Arab Republic in 1997 to that in 2001?
Offer a very short reply. 0.95. What is the ratio of the Number of enrolments of both sexes in Croatia in 1998 to that in 1999?
Make the answer very short. 1.02. What is the ratio of the Number of enrolments of both sexes of India in 1998 to that in 1999?
Your response must be concise. 0.98. What is the ratio of the Number of enrolments of both sexes in Poland in 1998 to that in 1999?
Ensure brevity in your answer.  1.43. What is the ratio of the Number of enrolments of both sexes in Syrian Arab Republic in 1998 to that in 1999?
Your answer should be very brief. 0.98. What is the ratio of the Number of enrolments of both sexes of Croatia in 1998 to that in 2000?
Make the answer very short. 1.04. What is the ratio of the Number of enrolments of both sexes of India in 1998 to that in 2000?
Your answer should be very brief. 0.96. What is the ratio of the Number of enrolments of both sexes in Poland in 1998 to that in 2000?
Provide a succinct answer. 1.48. What is the ratio of the Number of enrolments of both sexes of Syrian Arab Republic in 1998 to that in 2000?
Give a very brief answer. 0.97. What is the ratio of the Number of enrolments of both sexes in Croatia in 1998 to that in 2001?
Your answer should be very brief. 1.05. What is the ratio of the Number of enrolments of both sexes of India in 1998 to that in 2001?
Make the answer very short. 0.96. What is the ratio of the Number of enrolments of both sexes of Poland in 1998 to that in 2001?
Provide a short and direct response. 1.52. What is the ratio of the Number of enrolments of both sexes in Syrian Arab Republic in 1998 to that in 2001?
Your response must be concise. 0.95. What is the ratio of the Number of enrolments of both sexes of Croatia in 1999 to that in 2000?
Offer a terse response. 1.02. What is the ratio of the Number of enrolments of both sexes of India in 1999 to that in 2000?
Keep it short and to the point. 0.98. What is the ratio of the Number of enrolments of both sexes in Poland in 1999 to that in 2000?
Ensure brevity in your answer.  1.03. What is the ratio of the Number of enrolments of both sexes in Syrian Arab Republic in 1999 to that in 2000?
Offer a very short reply. 0.99. What is the ratio of the Number of enrolments of both sexes in Croatia in 1999 to that in 2001?
Provide a succinct answer. 1.04. What is the ratio of the Number of enrolments of both sexes in India in 1999 to that in 2001?
Provide a succinct answer. 0.97. What is the ratio of the Number of enrolments of both sexes in Poland in 1999 to that in 2001?
Your answer should be compact. 1.07. What is the ratio of the Number of enrolments of both sexes of Syrian Arab Republic in 1999 to that in 2001?
Provide a succinct answer. 0.97. What is the ratio of the Number of enrolments of both sexes in Croatia in 2000 to that in 2001?
Give a very brief answer. 1.02. What is the ratio of the Number of enrolments of both sexes of Poland in 2000 to that in 2001?
Keep it short and to the point. 1.03. What is the ratio of the Number of enrolments of both sexes in Syrian Arab Republic in 2000 to that in 2001?
Provide a succinct answer. 0.98. What is the difference between the highest and the second highest Number of enrolments of both sexes in Croatia?
Your answer should be very brief. 1769. What is the difference between the highest and the second highest Number of enrolments of both sexes of India?
Offer a terse response. 2.14e+05. What is the difference between the highest and the second highest Number of enrolments of both sexes in Poland?
Offer a terse response. 1.16e+06. What is the difference between the highest and the second highest Number of enrolments of both sexes of Syrian Arab Republic?
Provide a short and direct response. 6.01e+04. What is the difference between the highest and the lowest Number of enrolments of both sexes in Croatia?
Offer a terse response. 1.23e+04. What is the difference between the highest and the lowest Number of enrolments of both sexes in India?
Make the answer very short. 5.05e+06. What is the difference between the highest and the lowest Number of enrolments of both sexes of Poland?
Provide a short and direct response. 1.68e+06. What is the difference between the highest and the lowest Number of enrolments of both sexes of Syrian Arab Republic?
Provide a succinct answer. 1.62e+05. 